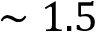Convert formula to latex. <formula><loc_0><loc_0><loc_500><loc_500>\sim 1 . 5</formula> 